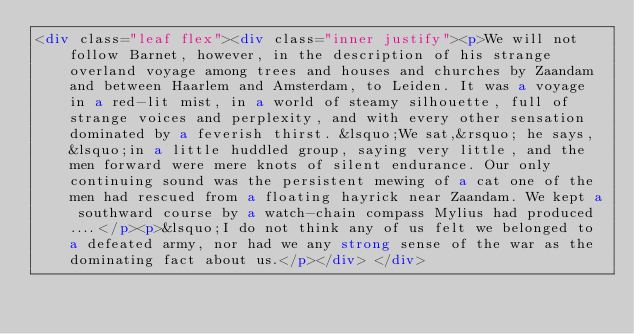Convert code to text. <code><loc_0><loc_0><loc_500><loc_500><_HTML_><div class="leaf flex"><div class="inner justify"><p>We will not follow Barnet, however, in the description of his strange overland voyage among trees and houses and churches by Zaandam and between Haarlem and Amsterdam, to Leiden. It was a voyage in a red-lit mist, in a world of steamy silhouette, full of strange voices and perplexity, and with every other sensation dominated by a feverish thirst. &lsquo;We sat,&rsquo; he says, &lsquo;in a little huddled group, saying very little, and the men forward were mere knots of silent endurance. Our only continuing sound was the persistent mewing of a cat one of the men had rescued from a floating hayrick near Zaandam. We kept a southward course by a watch-chain compass Mylius had produced....</p><p>&lsquo;I do not think any of us felt we belonged to a defeated army, nor had we any strong sense of the war as the dominating fact about us.</p></div> </div></code> 